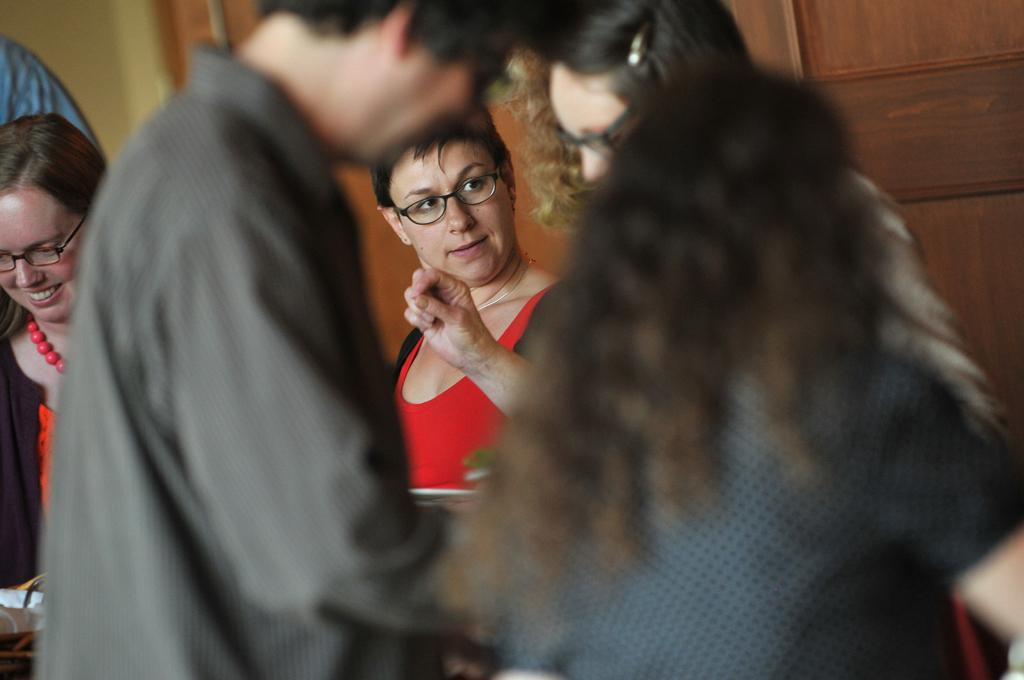How many people are in the image? There is a group of people standing in the image. Can you describe any specific features of the image? There is a wooden door in the image. What type of trick can be seen being performed with a quarter in the image? There is no trick or quarter present in the image. What is the group of people doing with the quiver in the image? There is no quiver present in the image. 